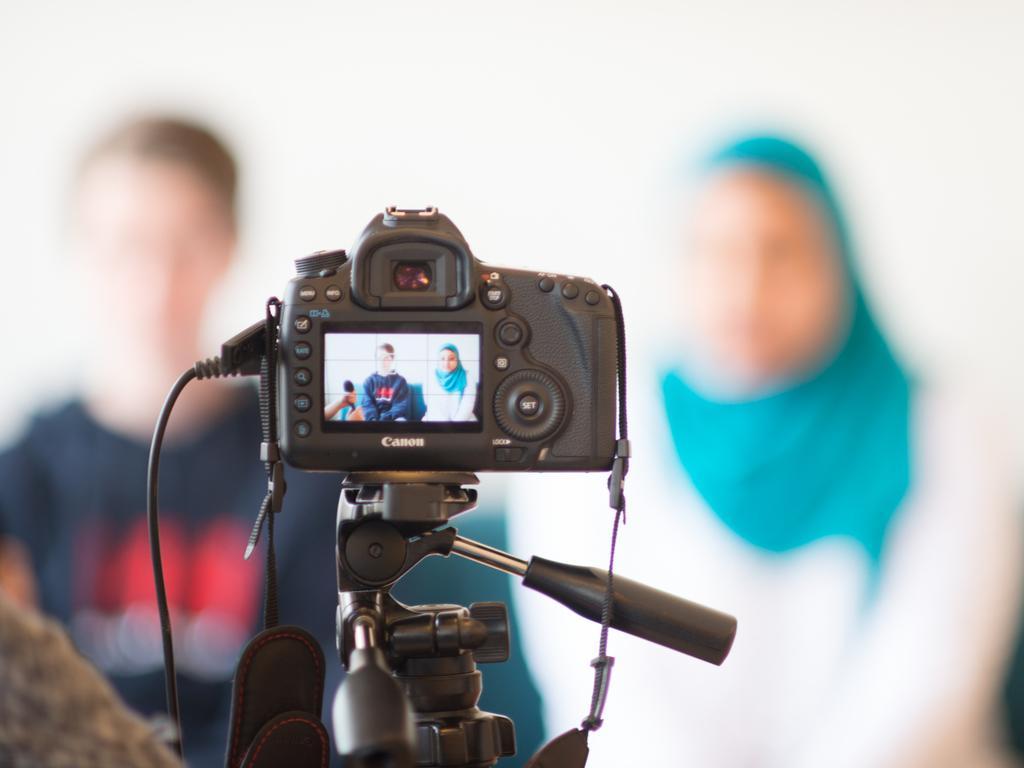How would you summarize this image in a sentence or two? In the image we can see there is a camera kept on the stand and on the screen there is a woman and a man are sitting on the sofa. Behind the image is little blurry. 